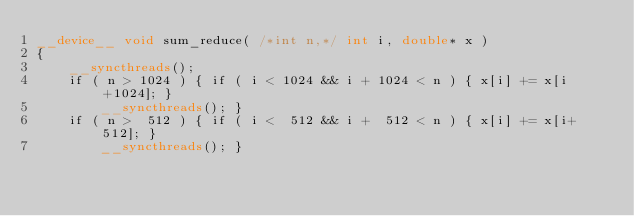<code> <loc_0><loc_0><loc_500><loc_500><_Cuda_>__device__ void sum_reduce( /*int n,*/ int i, double* x )
{
    __syncthreads();
    if ( n > 1024 ) { if ( i < 1024 && i + 1024 < n ) { x[i] += x[i+1024]; }  
        __syncthreads(); }
    if ( n >  512 ) { if ( i <  512 && i +  512 < n ) { x[i] += x[i+ 512]; }  
        __syncthreads(); }</code> 